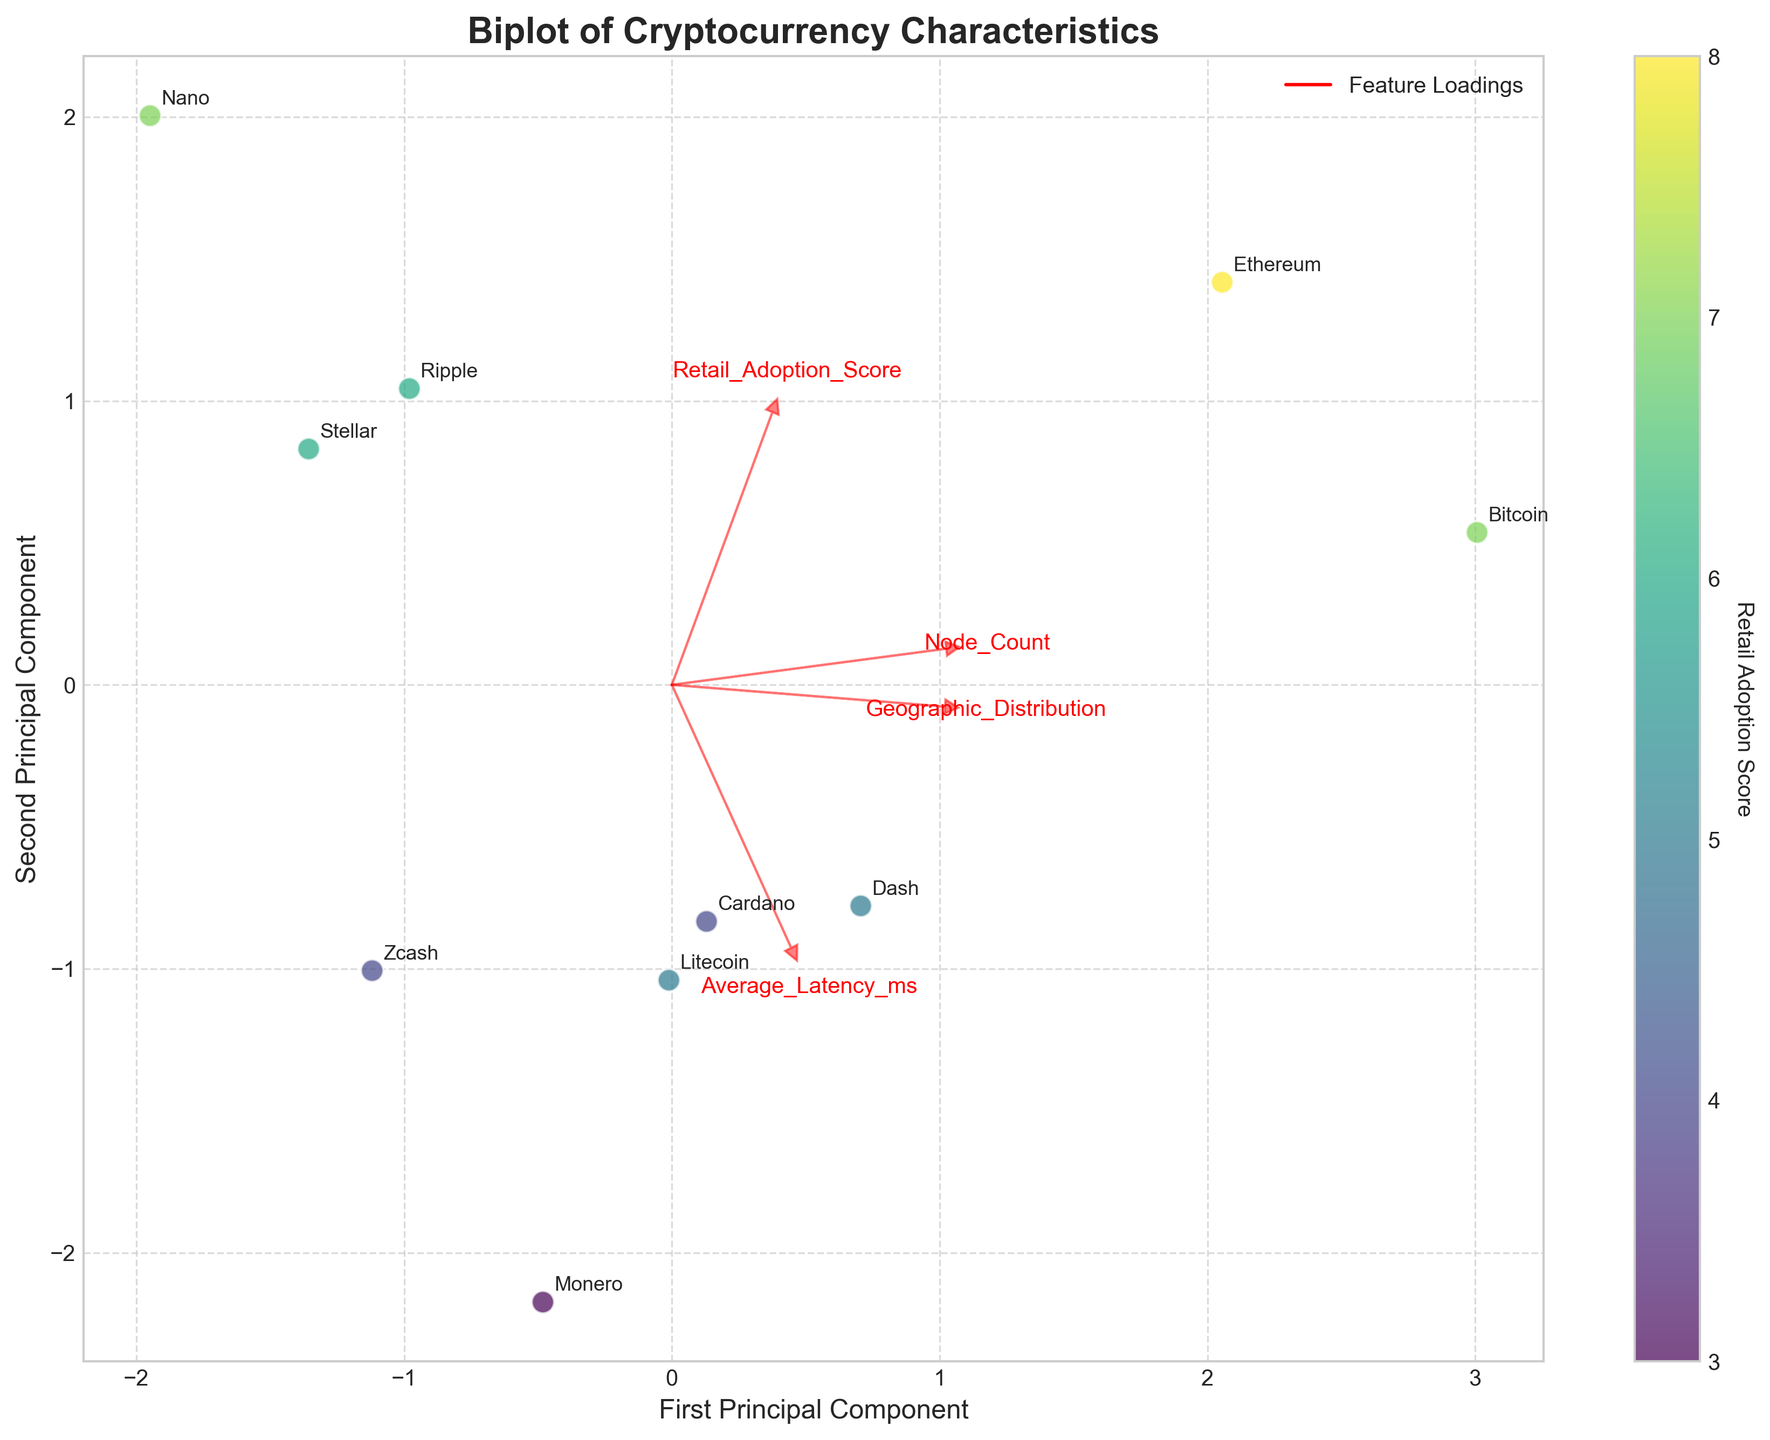What's the title of the plot? The title is clearly indicated at the top of the plot.
Answer: Biplot of Cryptocurrency Characteristics How many cryptocurrencies are represented in the plot? By counting the labeled data points for each cryptocurrency on the plot, we find there are 10 cryptocurrencies.
Answer: 10 Which cryptocurrency has the highest retail adoption score? By looking at the color intensity representing the retail adoption score, the cryptocurrency with the highest score will be darkest, and upon checking, it's Ethereum.
Answer: Ethereum Which cryptocurrency has the lowest node count? By checking the biplot and understanding the features' loadings (arrows), we identify Nano as the cryptocurrency closest to the origin along the Node_Count direction, indicating it has the lowest node count.
Answer: Nano What two characteristics have the highest loading on the first principal component (PC1)? By observing the red arrows, the features with arrows closest to the direction of PC1 are Node_Count and Retail_Adoption_Score.
Answer: Node_Count and Retail_Adoption_Score Which two cryptocurrencies have similar positions in the biplot? By examining the proximity of the data points, Bitcoin and Zcash appear to be close to each other in the biplot.
Answer: Bitcoin and Zcash How does the geographic distribution correlate with the average latency? By following the directions of the Geographic_Distribution and Average_Latency_ms loadings (arrows), we see that they are nearly opposite, indicating a negative correlation.
Answer: Negatively correlated Which cryptocurrency is associated with the highest average latency? Referring to the data points in the direction aligned most with the Average_Latency_ms arrow, Monero is the farthest along this direction, indicating the highest average latency.
Answer: Monero Which feature has the least impact on both principal components? The feature with the shortest arrow length indicates the least impact, which in this case is Geographic_Distribution.
Answer: Geographic_Distribution Which cryptocurrencies form a cluster suggesting similar characteristics in the context of this visualization? By observing clusters of closely positioned data points, Bitcoin, Ethereum, and Dash form a cluster suggesting they have similar characteristics.
Answer: Bitcoin, Ethereum, and Dash 